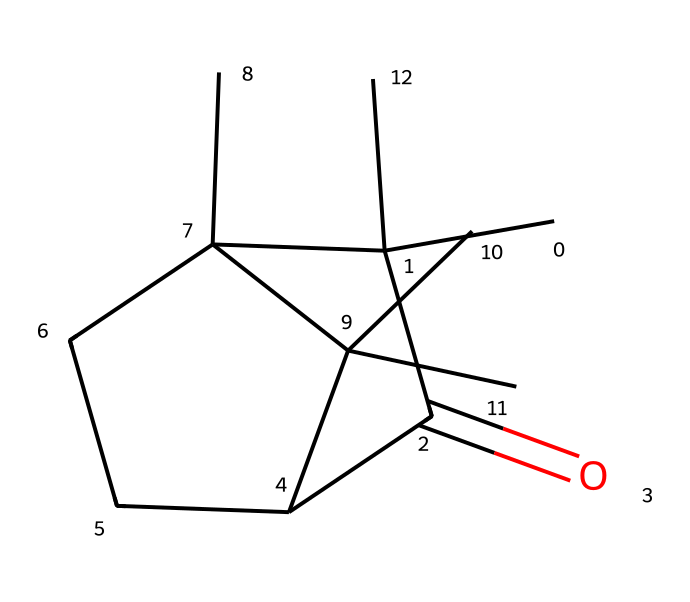What is the molecular formula of camphor? By analyzing the SMILES representation, we can discern the number of carbon (C), hydrogen (H), and oxygen (O) atoms present. The structure indicates 10 carbons, 16 hydrogens, and 1 oxygen, leading us to deduce the molecular formula as C10H16O.
Answer: C10H16O How many rings are present in the structure of camphor? The SMILES representation shows two cyclic structures (C1 and C2), indicating that there are two rings in the molecule.
Answer: 2 What type of functional group is present in camphor? Looking closely at the structure, we see the carbonyl group (C=O), which is characteristic of ketones and indicates that the molecule is a ketone.
Answer: ketone What is the degree of saturation of camphor? To determine saturation, we count the total number of pi bonds and rings. With two rings and one carbonyl group, we can deduce it follows the rules of degree of unsaturation, resulting in a degree of saturation of 3.
Answer: 3 Which part of the molecule is responsible for its ketone classification? The carbonyl group (C=O) is a distinctive feature that signifies the classification of camphor as a ketone, as it is connected to two carbon atoms.
Answer: carbonyl group What is the total number of hydrogen atoms in camphor? By examining the SMILES representation, we can sum the hydrogen connections (keeping in mind the tetravalency of carbon) which yields a total of 16 hydrogen atoms in the structure.
Answer: 16 